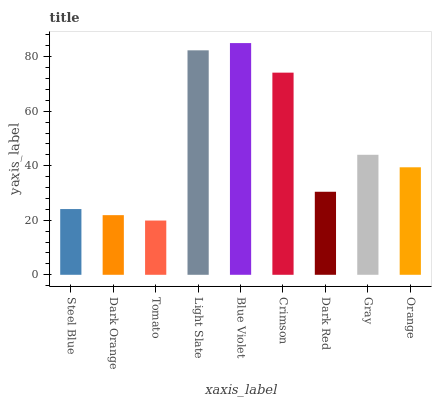Is Tomato the minimum?
Answer yes or no. Yes. Is Blue Violet the maximum?
Answer yes or no. Yes. Is Dark Orange the minimum?
Answer yes or no. No. Is Dark Orange the maximum?
Answer yes or no. No. Is Steel Blue greater than Dark Orange?
Answer yes or no. Yes. Is Dark Orange less than Steel Blue?
Answer yes or no. Yes. Is Dark Orange greater than Steel Blue?
Answer yes or no. No. Is Steel Blue less than Dark Orange?
Answer yes or no. No. Is Orange the high median?
Answer yes or no. Yes. Is Orange the low median?
Answer yes or no. Yes. Is Steel Blue the high median?
Answer yes or no. No. Is Tomato the low median?
Answer yes or no. No. 